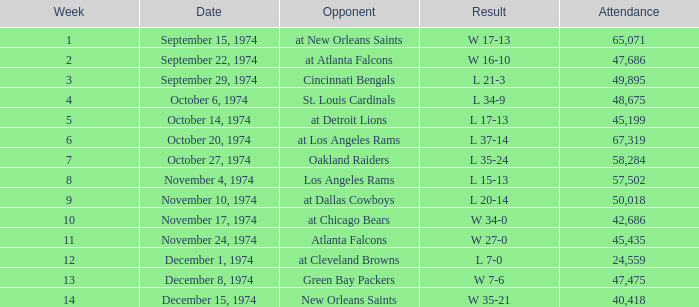What was the turnout when they played at detroit lions? 45199.0. 